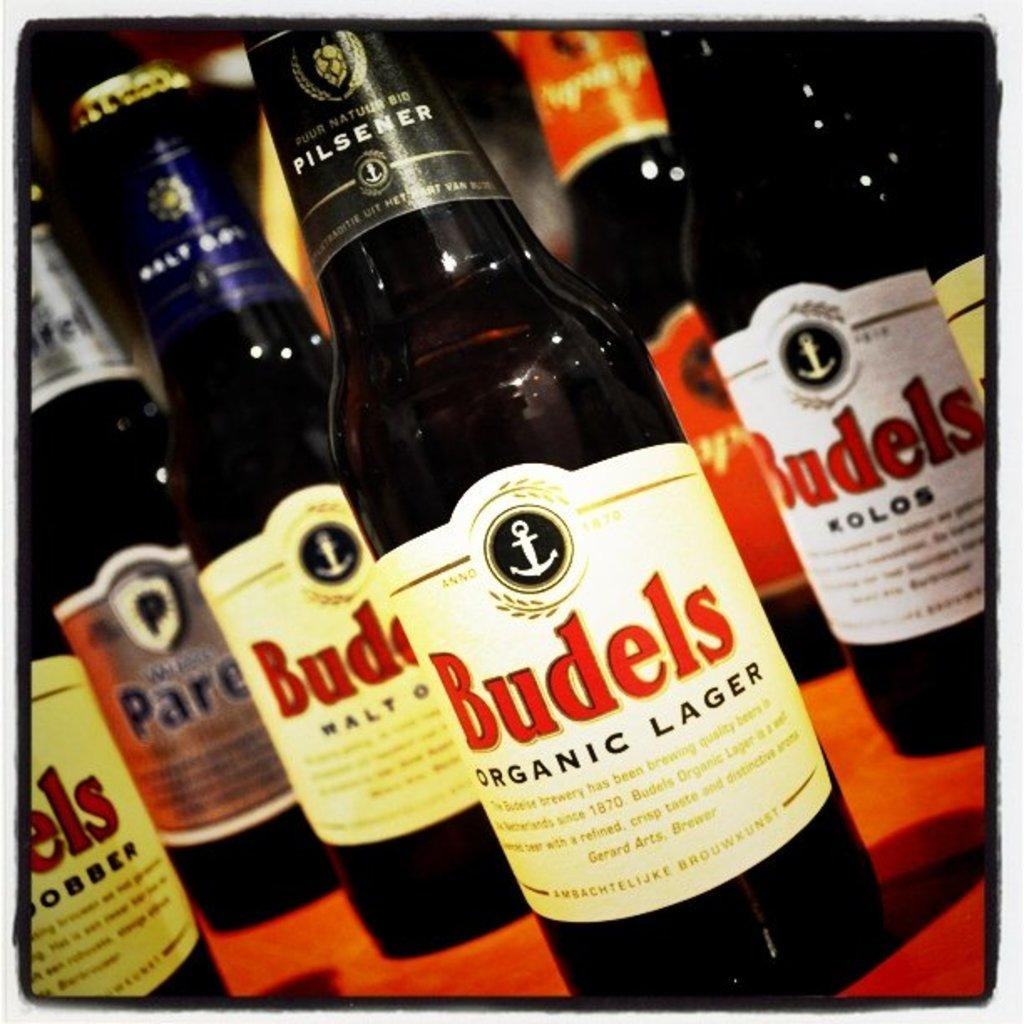Provide a one-sentence caption for the provided image. A bottle of Budels lager has a little anchor icon on the label. 